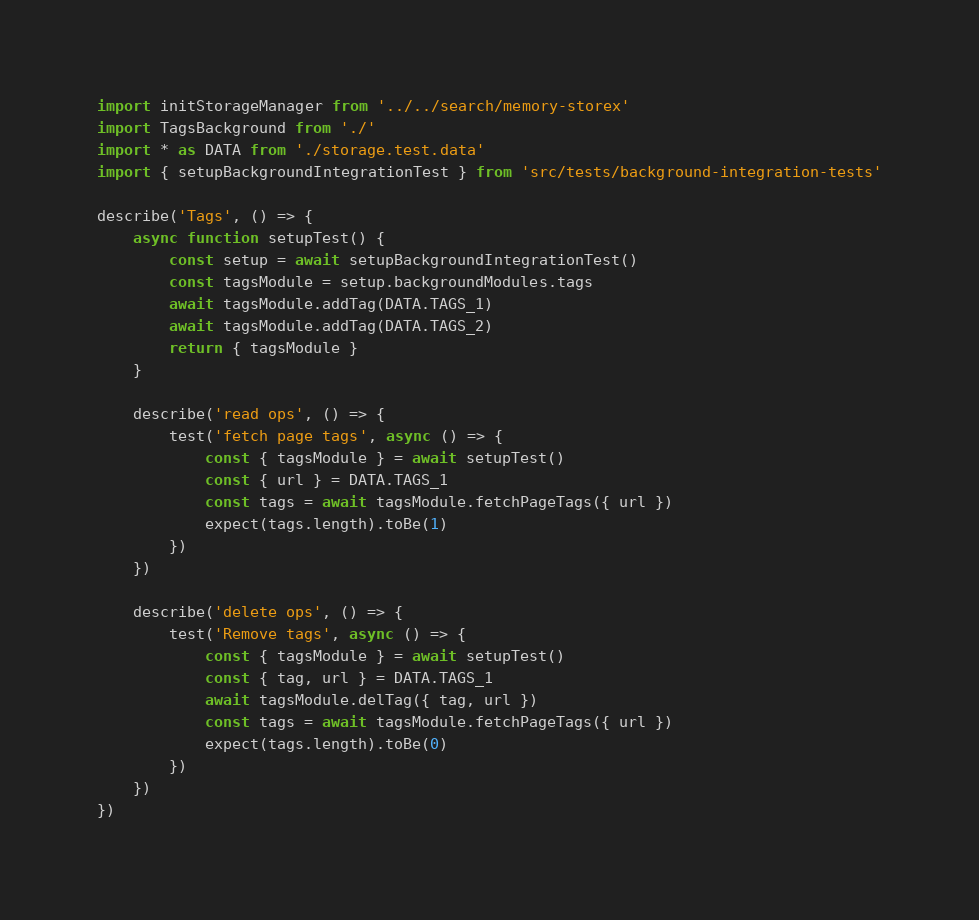Convert code to text. <code><loc_0><loc_0><loc_500><loc_500><_TypeScript_>import initStorageManager from '../../search/memory-storex'
import TagsBackground from './'
import * as DATA from './storage.test.data'
import { setupBackgroundIntegrationTest } from 'src/tests/background-integration-tests'

describe('Tags', () => {
    async function setupTest() {
        const setup = await setupBackgroundIntegrationTest()
        const tagsModule = setup.backgroundModules.tags
        await tagsModule.addTag(DATA.TAGS_1)
        await tagsModule.addTag(DATA.TAGS_2)
        return { tagsModule }
    }

    describe('read ops', () => {
        test('fetch page tags', async () => {
            const { tagsModule } = await setupTest()
            const { url } = DATA.TAGS_1
            const tags = await tagsModule.fetchPageTags({ url })
            expect(tags.length).toBe(1)
        })
    })

    describe('delete ops', () => {
        test('Remove tags', async () => {
            const { tagsModule } = await setupTest()
            const { tag, url } = DATA.TAGS_1
            await tagsModule.delTag({ tag, url })
            const tags = await tagsModule.fetchPageTags({ url })
            expect(tags.length).toBe(0)
        })
    })
})
</code> 